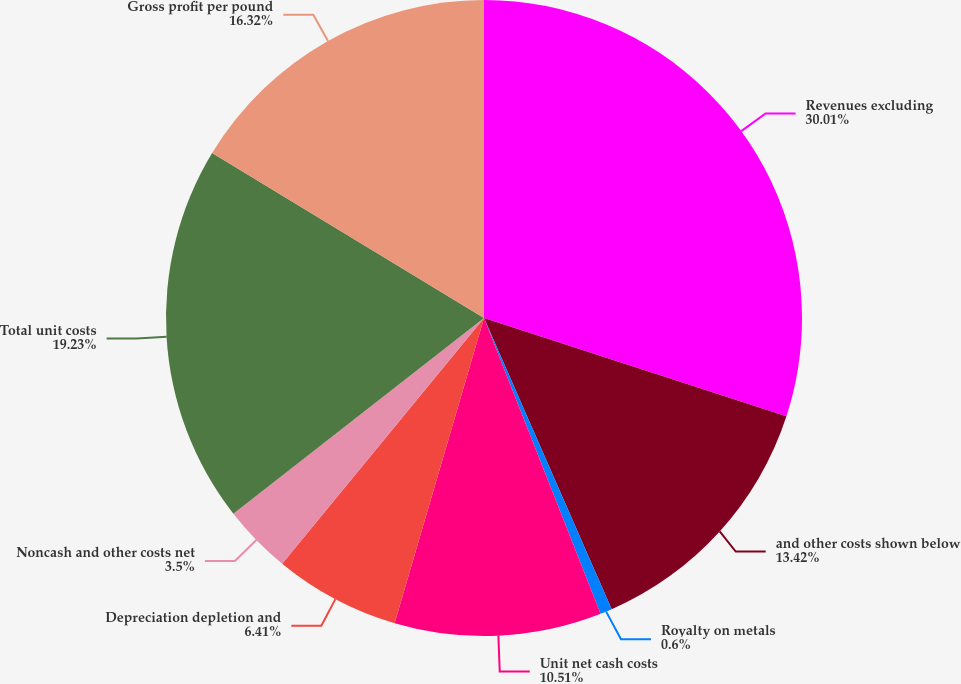Convert chart. <chart><loc_0><loc_0><loc_500><loc_500><pie_chart><fcel>Revenues excluding<fcel>and other costs shown below<fcel>Royalty on metals<fcel>Unit net cash costs<fcel>Depreciation depletion and<fcel>Noncash and other costs net<fcel>Total unit costs<fcel>Gross profit per pound<nl><fcel>30.0%<fcel>13.42%<fcel>0.6%<fcel>10.51%<fcel>6.41%<fcel>3.5%<fcel>19.23%<fcel>16.32%<nl></chart> 